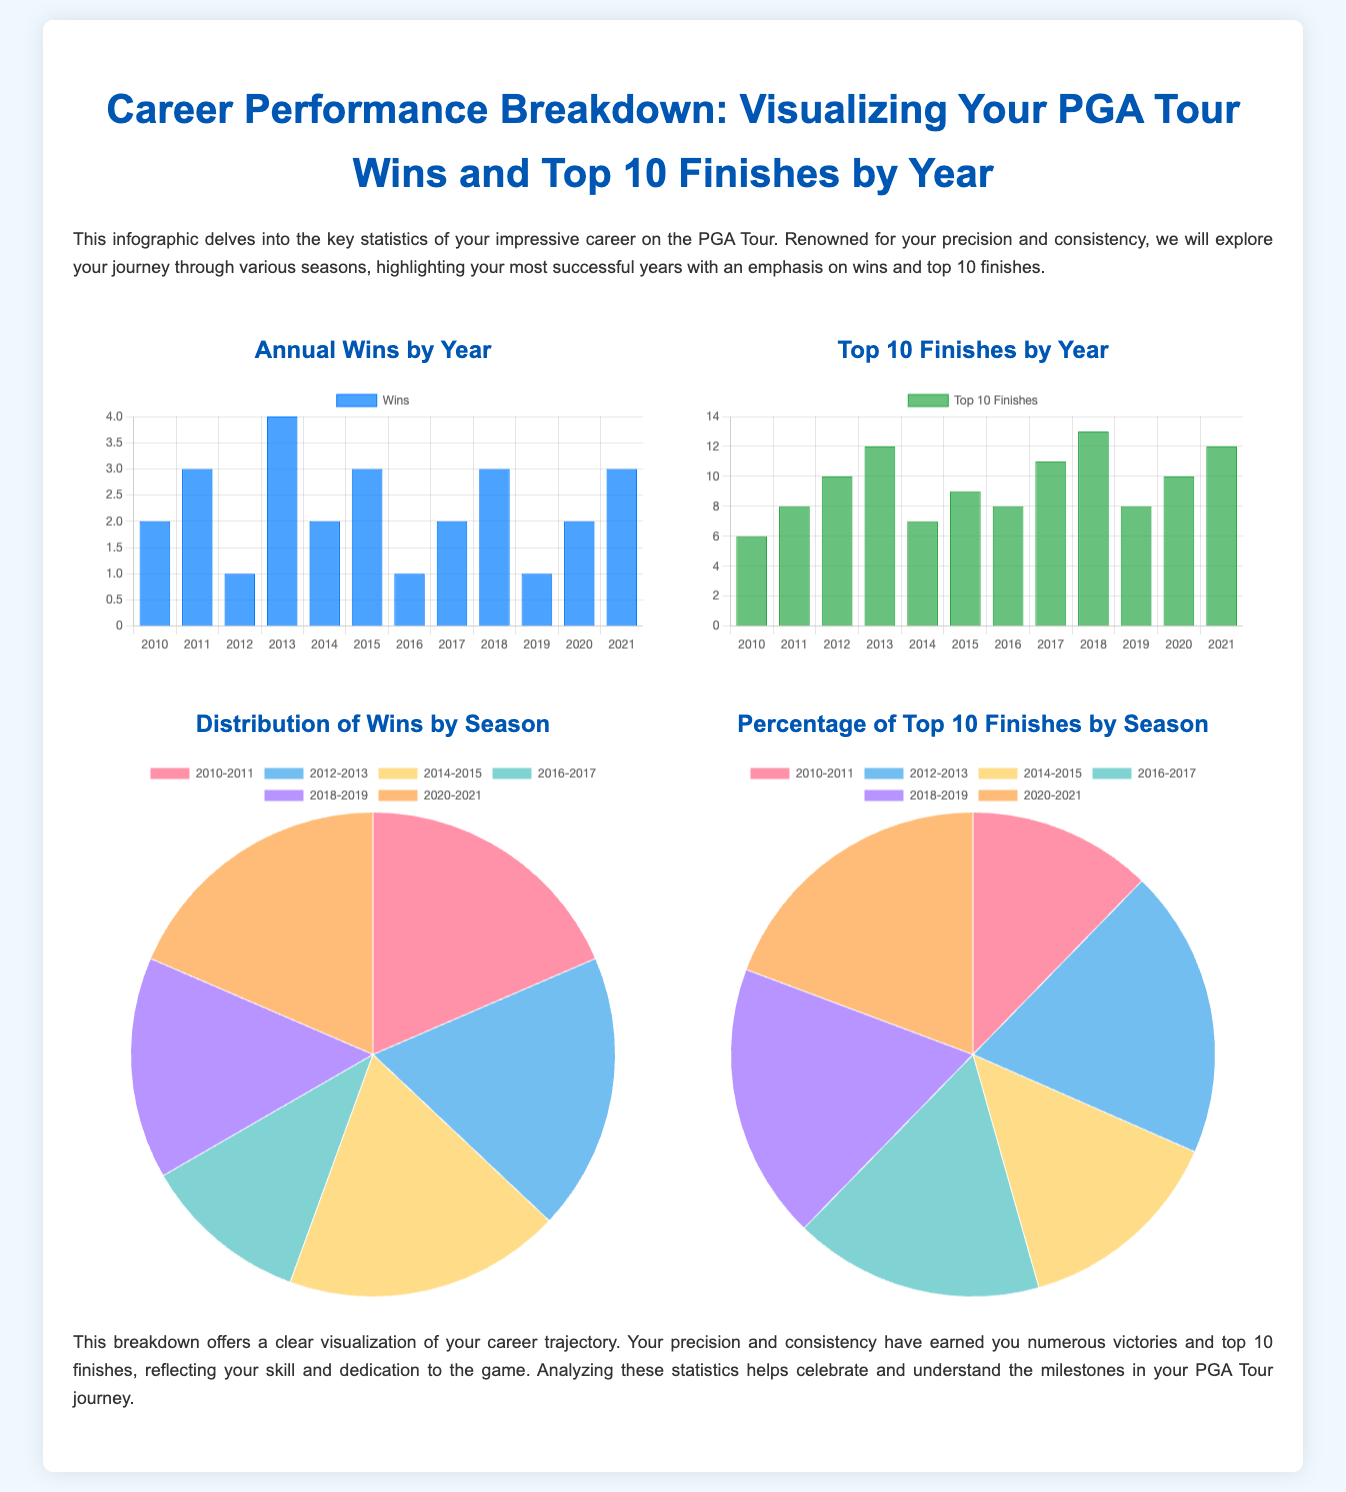What is the year with the highest wins? The chart shows that 2013 has the most wins with 4.
Answer: 2013 How many top 10 finishes did you have in 2015? Referring to the bar chart for Top 10 Finishes, the value for 2015 is 9.
Answer: 9 Which two years had the same number of wins? From the bar chart, the years 2010 and 2014 both had 2 wins.
Answer: 2010 and 2014 What is the total number of top 10 finishes from 2010 to 2021? The total is obtained by adding the top 10 finishes for each year: 6 + 8 + 10 + 12 + 7 + 9 + 8 + 11 + 13 + 8 + 10 + 12 =  76.
Answer: 76 Which season had the highest distribution of wins? From the pie chart showing the distribution of wins, the season 2010-2011 had the highest with 5 wins.
Answer: 2010-2011 What percentage of top 10 finishes did you achieve in 2018-2019? The pie chart for top 10 finishes highlights that 21% of finishes were during the season 2018-2019.
Answer: 21% What is the total number of wins from 2010 to 2021? By adding the wins for each year: 2 + 3 + 1 + 4 + 2 + 3 + 1 + 2 + 3 + 1 + 2 + 3 = 24 wins in total.
Answer: 24 What type of chart shows your annual wins by year? The infographic specifies that it uses a bar chart to represent annual wins.
Answer: Bar chart 